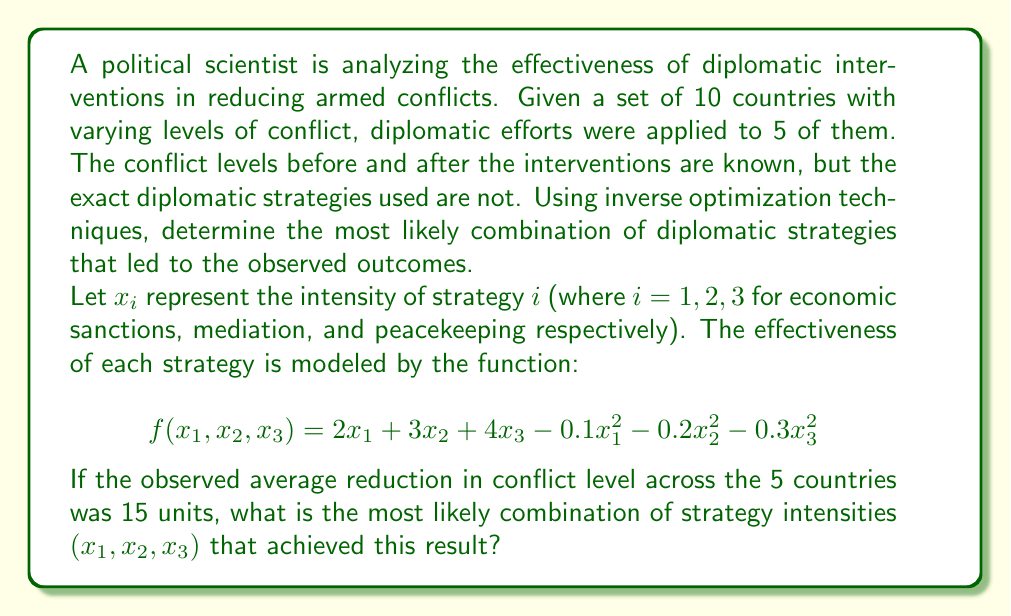Can you solve this math problem? To solve this inverse optimization problem, we need to follow these steps:

1) First, we need to set up the optimization problem. We want to maximize the effectiveness function subject to the constraint that the total effectiveness equals 15:

   Maximize: $f(x_1, x_2, x_3) = 2x_1 + 3x_2 + 4x_3 - 0.1x_1^2 - 0.2x_2^2 - 0.3x_3^2$
   Subject to: $f(x_1, x_2, x_3) = 15$

2) To solve this, we can use the method of Lagrange multipliers. We form the Lagrangian:

   $L(x_1, x_2, x_3, \lambda) = 2x_1 + 3x_2 + 4x_3 - 0.1x_1^2 - 0.2x_2^2 - 0.3x_3^2 - \lambda(2x_1 + 3x_2 + 4x_3 - 0.1x_1^2 - 0.2x_2^2 - 0.3x_3^2 - 15)$

3) We then take partial derivatives and set them to zero:

   $\frac{\partial L}{\partial x_1} = 2 - 0.2x_1 - \lambda(2 - 0.2x_1) = 0$
   $\frac{\partial L}{\partial x_2} = 3 - 0.4x_2 - \lambda(3 - 0.4x_2) = 0$
   $\frac{\partial L}{\partial x_3} = 4 - 0.6x_3 - \lambda(4 - 0.6x_3) = 0$
   $\frac{\partial L}{\partial \lambda} = 2x_1 + 3x_2 + 4x_3 - 0.1x_1^2 - 0.2x_2^2 - 0.3x_3^2 - 15 = 0$

4) From the first three equations, we can derive:

   $x_1 = \frac{10}{1+\lambda}$, $x_2 = \frac{15}{2+2\lambda}$, $x_3 = \frac{20}{3+3\lambda}$

5) Substituting these into the fourth equation:

   $2(\frac{10}{1+\lambda}) + 3(\frac{15}{2+2\lambda}) + 4(\frac{20}{3+3\lambda}) - 0.1(\frac{10}{1+\lambda})^2 - 0.2(\frac{15}{2+2\lambda})^2 - 0.3(\frac{20}{3+3\lambda})^2 = 15$

6) This equation can be solved numerically to find $\lambda \approx 0.5385$

7) Substituting this value back into the expressions for $x_1$, $x_2$, and $x_3$:

   $x_1 \approx 6.5$, $x_2 \approx 5.85$, $x_3 \approx 5.2$

These values represent the most likely intensities of each diplomatic strategy that resulted in the observed conflict reduction.
Answer: $(x_1, x_2, x_3) \approx (6.5, 5.85, 5.2)$ 